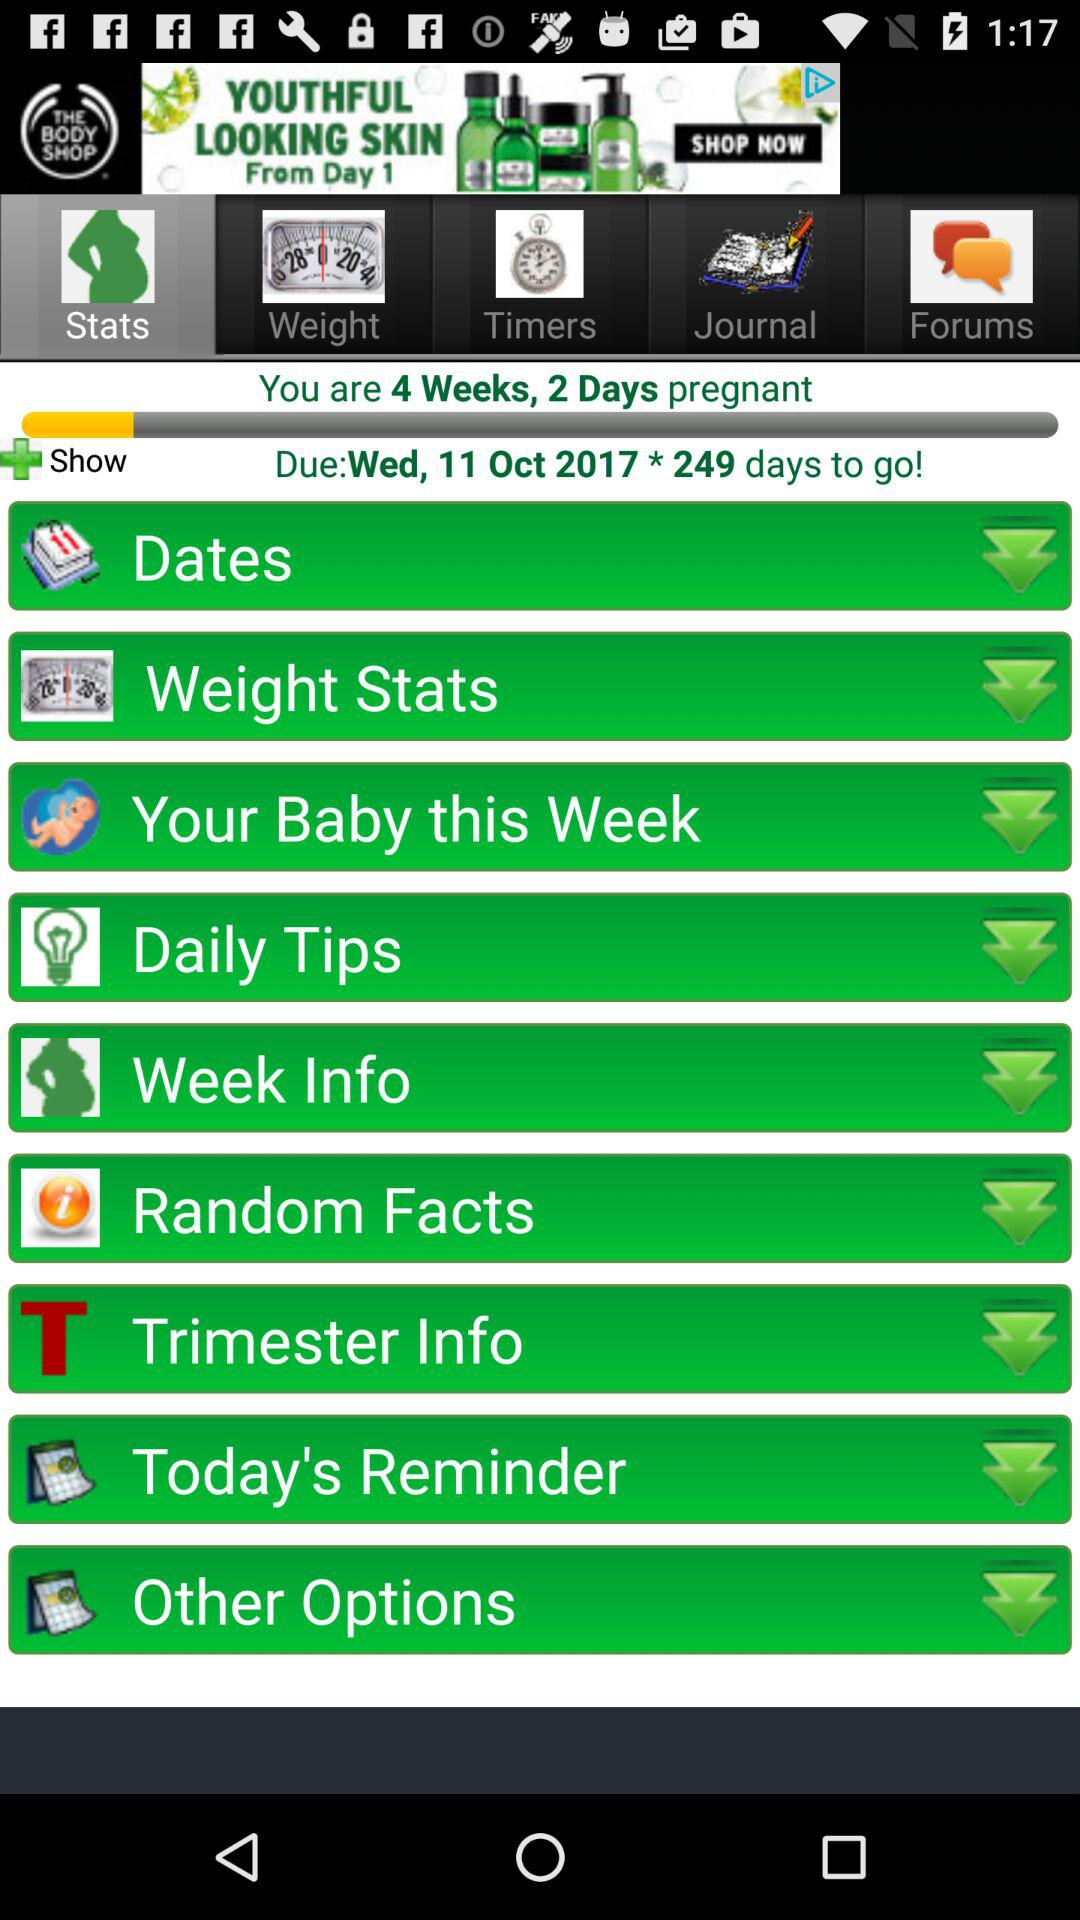What is the due date of the pregnancy? The due date is Wednesday, October 11, 2017. 